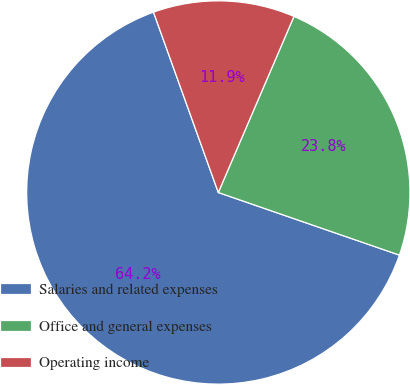Convert chart. <chart><loc_0><loc_0><loc_500><loc_500><pie_chart><fcel>Salaries and related expenses<fcel>Office and general expenses<fcel>Operating income<nl><fcel>64.21%<fcel>23.84%<fcel>11.95%<nl></chart> 